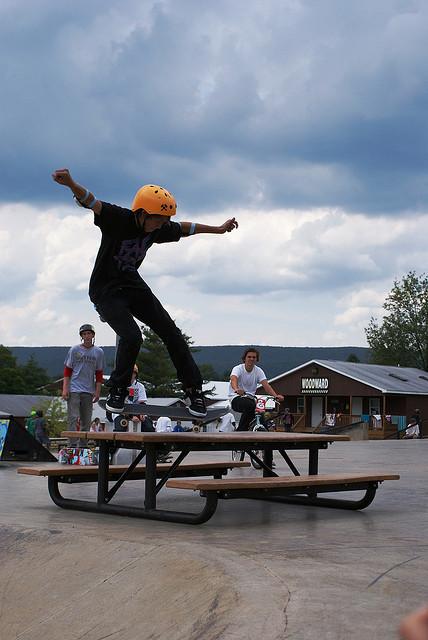Is this a skate park?
Answer briefly. No. Is there food on the table?
Be succinct. No. What color beanie is the boy wearing?
Concise answer only. Orange. Will this skateboarder continue skating to the edge of the picnic table?
Write a very short answer. Yes. What is under his feet?
Concise answer only. Skateboard. 